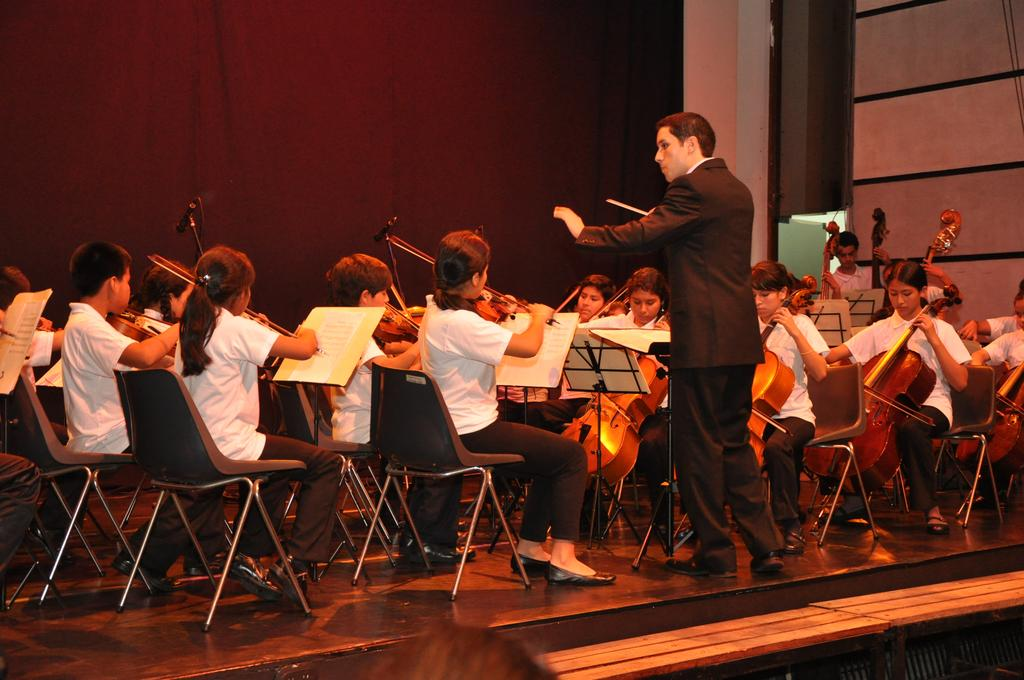What are the persons in the image doing? The persons in the image are sitting on chairs and playing violins. Can you describe the man in the image? The man is standing and holding a stick. What can be seen in the background of the image? There is a red curtain in the image. Can you tell me how many eyes are visible on the kite in the image? There is no kite present in the image, so it is not possible to determine how many eyes are visible on it. 